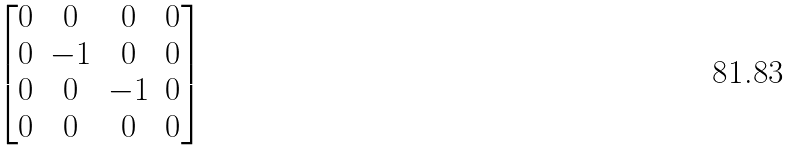<formula> <loc_0><loc_0><loc_500><loc_500>\begin{bmatrix} 0 & 0 & 0 & 0 \\ 0 & - 1 & 0 & 0 \\ 0 & 0 & - 1 & 0 \\ 0 & 0 & 0 & 0 \end{bmatrix}</formula> 